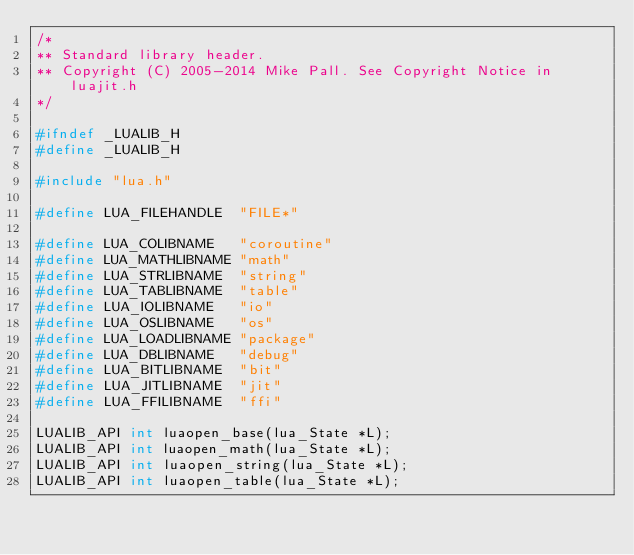<code> <loc_0><loc_0><loc_500><loc_500><_C_>/*
** Standard library header.
** Copyright (C) 2005-2014 Mike Pall. See Copyright Notice in luajit.h
*/

#ifndef _LUALIB_H
#define _LUALIB_H

#include "lua.h"

#define LUA_FILEHANDLE	"FILE*"

#define LUA_COLIBNAME	"coroutine"
#define LUA_MATHLIBNAME	"math"
#define LUA_STRLIBNAME	"string"
#define LUA_TABLIBNAME	"table"
#define LUA_IOLIBNAME	"io"
#define LUA_OSLIBNAME	"os"
#define LUA_LOADLIBNAME	"package"
#define LUA_DBLIBNAME	"debug"
#define LUA_BITLIBNAME	"bit"
#define LUA_JITLIBNAME	"jit"
#define LUA_FFILIBNAME	"ffi"

LUALIB_API int luaopen_base(lua_State *L);
LUALIB_API int luaopen_math(lua_State *L);
LUALIB_API int luaopen_string(lua_State *L);
LUALIB_API int luaopen_table(lua_State *L);</code> 